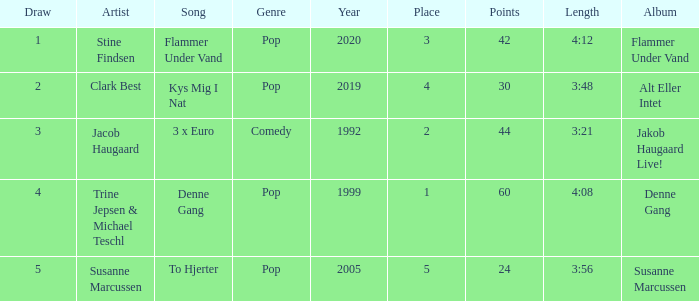What is the average Draw when the Place is larger than 5? None. 